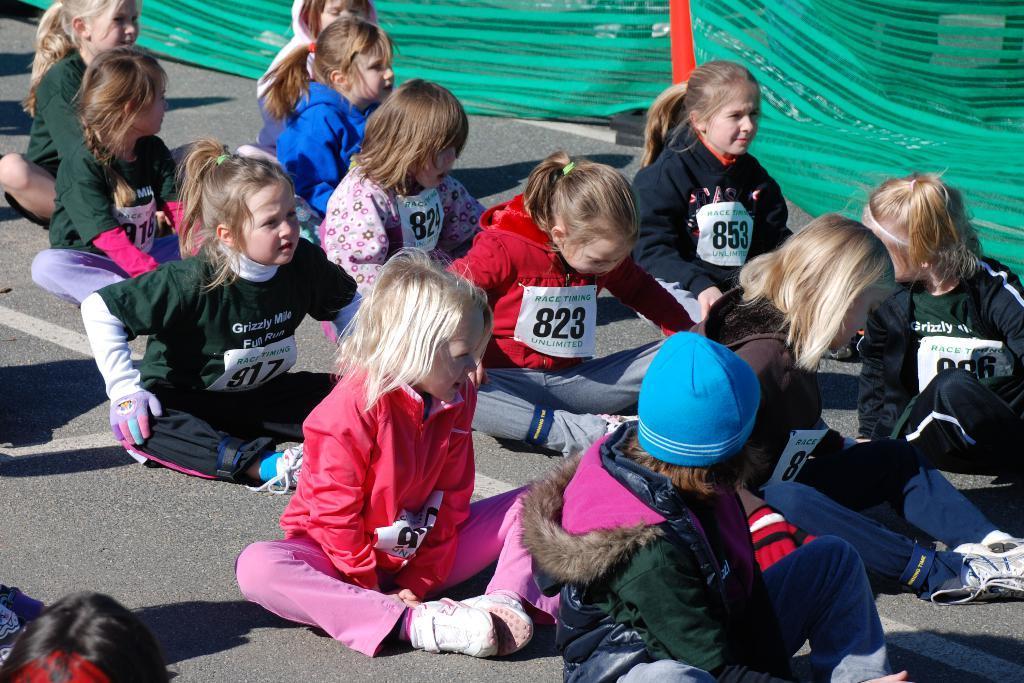How would you summarize this image in a sentence or two? On the right side of the picture we can see green color cloth. In this picture we can see children sitting on the road. We can see sticky notes with number digits on their dresses. 